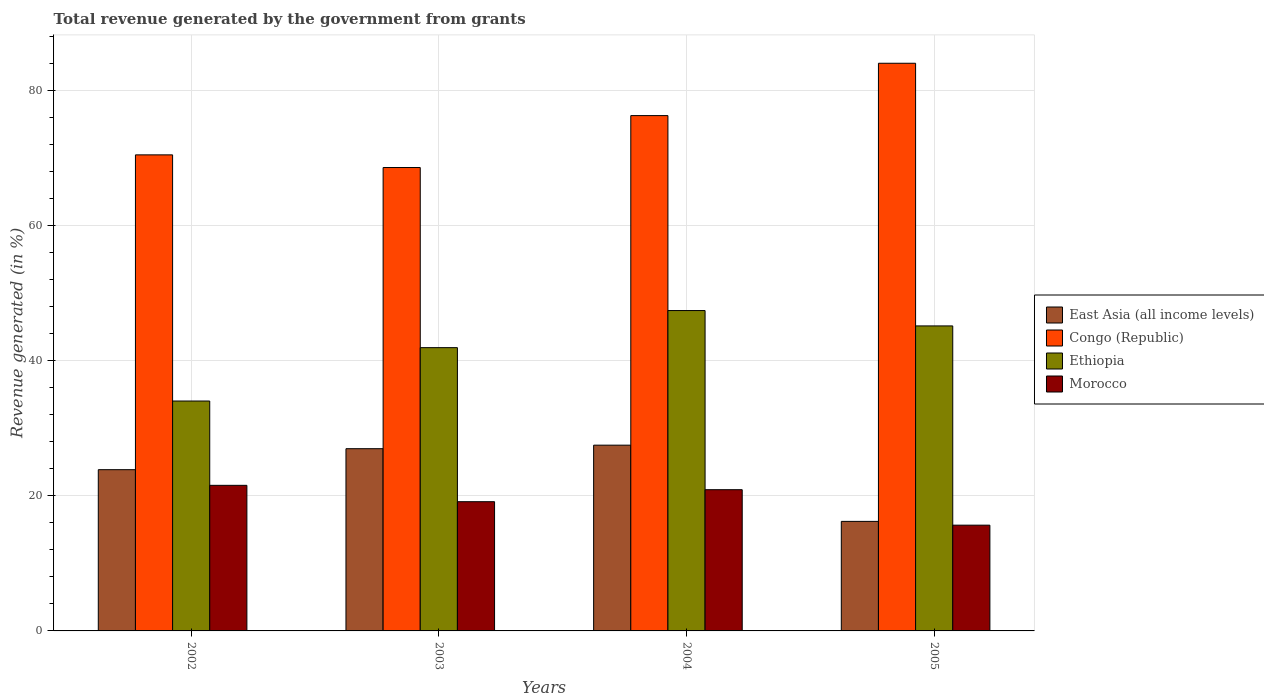How many different coloured bars are there?
Offer a terse response. 4. How many bars are there on the 1st tick from the right?
Ensure brevity in your answer.  4. What is the label of the 4th group of bars from the left?
Ensure brevity in your answer.  2005. In how many cases, is the number of bars for a given year not equal to the number of legend labels?
Your answer should be compact. 0. What is the total revenue generated in Congo (Republic) in 2004?
Make the answer very short. 76.32. Across all years, what is the maximum total revenue generated in Ethiopia?
Offer a very short reply. 47.45. Across all years, what is the minimum total revenue generated in Ethiopia?
Give a very brief answer. 34.05. In which year was the total revenue generated in Morocco maximum?
Offer a very short reply. 2002. What is the total total revenue generated in Morocco in the graph?
Your answer should be very brief. 77.28. What is the difference between the total revenue generated in Ethiopia in 2002 and that in 2003?
Provide a succinct answer. -7.91. What is the difference between the total revenue generated in Ethiopia in 2005 and the total revenue generated in East Asia (all income levels) in 2002?
Offer a very short reply. 21.29. What is the average total revenue generated in Morocco per year?
Give a very brief answer. 19.32. In the year 2004, what is the difference between the total revenue generated in East Asia (all income levels) and total revenue generated in Congo (Republic)?
Your answer should be compact. -48.81. In how many years, is the total revenue generated in Morocco greater than 64 %?
Your answer should be compact. 0. What is the ratio of the total revenue generated in Ethiopia in 2004 to that in 2005?
Your answer should be compact. 1.05. What is the difference between the highest and the second highest total revenue generated in Congo (Republic)?
Keep it short and to the point. 7.75. What is the difference between the highest and the lowest total revenue generated in Ethiopia?
Your answer should be very brief. 13.4. Is the sum of the total revenue generated in Ethiopia in 2004 and 2005 greater than the maximum total revenue generated in Morocco across all years?
Your answer should be very brief. Yes. What does the 4th bar from the left in 2002 represents?
Provide a short and direct response. Morocco. What does the 1st bar from the right in 2003 represents?
Provide a short and direct response. Morocco. How many bars are there?
Offer a very short reply. 16. Are all the bars in the graph horizontal?
Provide a succinct answer. No. Does the graph contain any zero values?
Your answer should be very brief. No. What is the title of the graph?
Make the answer very short. Total revenue generated by the government from grants. Does "Barbados" appear as one of the legend labels in the graph?
Make the answer very short. No. What is the label or title of the X-axis?
Your answer should be compact. Years. What is the label or title of the Y-axis?
Keep it short and to the point. Revenue generated (in %). What is the Revenue generated (in %) in East Asia (all income levels) in 2002?
Give a very brief answer. 23.88. What is the Revenue generated (in %) of Congo (Republic) in 2002?
Your answer should be compact. 70.51. What is the Revenue generated (in %) in Ethiopia in 2002?
Your answer should be compact. 34.05. What is the Revenue generated (in %) of Morocco in 2002?
Your answer should be compact. 21.56. What is the Revenue generated (in %) of East Asia (all income levels) in 2003?
Ensure brevity in your answer.  26.99. What is the Revenue generated (in %) in Congo (Republic) in 2003?
Provide a short and direct response. 68.63. What is the Revenue generated (in %) of Ethiopia in 2003?
Your answer should be compact. 41.96. What is the Revenue generated (in %) of Morocco in 2003?
Offer a terse response. 19.14. What is the Revenue generated (in %) in East Asia (all income levels) in 2004?
Ensure brevity in your answer.  27.51. What is the Revenue generated (in %) of Congo (Republic) in 2004?
Your answer should be very brief. 76.32. What is the Revenue generated (in %) in Ethiopia in 2004?
Provide a short and direct response. 47.45. What is the Revenue generated (in %) in Morocco in 2004?
Your answer should be very brief. 20.92. What is the Revenue generated (in %) of East Asia (all income levels) in 2005?
Your answer should be compact. 16.22. What is the Revenue generated (in %) of Congo (Republic) in 2005?
Your answer should be compact. 84.08. What is the Revenue generated (in %) of Ethiopia in 2005?
Your answer should be very brief. 45.17. What is the Revenue generated (in %) in Morocco in 2005?
Offer a terse response. 15.66. Across all years, what is the maximum Revenue generated (in %) of East Asia (all income levels)?
Provide a short and direct response. 27.51. Across all years, what is the maximum Revenue generated (in %) in Congo (Republic)?
Keep it short and to the point. 84.08. Across all years, what is the maximum Revenue generated (in %) of Ethiopia?
Offer a very short reply. 47.45. Across all years, what is the maximum Revenue generated (in %) in Morocco?
Your answer should be compact. 21.56. Across all years, what is the minimum Revenue generated (in %) in East Asia (all income levels)?
Provide a succinct answer. 16.22. Across all years, what is the minimum Revenue generated (in %) of Congo (Republic)?
Keep it short and to the point. 68.63. Across all years, what is the minimum Revenue generated (in %) in Ethiopia?
Provide a short and direct response. 34.05. Across all years, what is the minimum Revenue generated (in %) in Morocco?
Offer a very short reply. 15.66. What is the total Revenue generated (in %) in East Asia (all income levels) in the graph?
Your answer should be very brief. 94.61. What is the total Revenue generated (in %) in Congo (Republic) in the graph?
Give a very brief answer. 299.54. What is the total Revenue generated (in %) in Ethiopia in the graph?
Your answer should be compact. 168.63. What is the total Revenue generated (in %) of Morocco in the graph?
Your response must be concise. 77.28. What is the difference between the Revenue generated (in %) in East Asia (all income levels) in 2002 and that in 2003?
Offer a very short reply. -3.11. What is the difference between the Revenue generated (in %) of Congo (Republic) in 2002 and that in 2003?
Offer a terse response. 1.88. What is the difference between the Revenue generated (in %) of Ethiopia in 2002 and that in 2003?
Give a very brief answer. -7.91. What is the difference between the Revenue generated (in %) of Morocco in 2002 and that in 2003?
Provide a short and direct response. 2.42. What is the difference between the Revenue generated (in %) in East Asia (all income levels) in 2002 and that in 2004?
Give a very brief answer. -3.63. What is the difference between the Revenue generated (in %) of Congo (Republic) in 2002 and that in 2004?
Keep it short and to the point. -5.81. What is the difference between the Revenue generated (in %) of Ethiopia in 2002 and that in 2004?
Offer a terse response. -13.4. What is the difference between the Revenue generated (in %) in Morocco in 2002 and that in 2004?
Offer a terse response. 0.65. What is the difference between the Revenue generated (in %) of East Asia (all income levels) in 2002 and that in 2005?
Your answer should be very brief. 7.66. What is the difference between the Revenue generated (in %) in Congo (Republic) in 2002 and that in 2005?
Offer a terse response. -13.57. What is the difference between the Revenue generated (in %) of Ethiopia in 2002 and that in 2005?
Provide a short and direct response. -11.12. What is the difference between the Revenue generated (in %) in Morocco in 2002 and that in 2005?
Give a very brief answer. 5.9. What is the difference between the Revenue generated (in %) of East Asia (all income levels) in 2003 and that in 2004?
Provide a short and direct response. -0.52. What is the difference between the Revenue generated (in %) of Congo (Republic) in 2003 and that in 2004?
Give a very brief answer. -7.69. What is the difference between the Revenue generated (in %) of Ethiopia in 2003 and that in 2004?
Ensure brevity in your answer.  -5.49. What is the difference between the Revenue generated (in %) in Morocco in 2003 and that in 2004?
Your answer should be compact. -1.78. What is the difference between the Revenue generated (in %) in East Asia (all income levels) in 2003 and that in 2005?
Offer a terse response. 10.77. What is the difference between the Revenue generated (in %) of Congo (Republic) in 2003 and that in 2005?
Ensure brevity in your answer.  -15.44. What is the difference between the Revenue generated (in %) in Ethiopia in 2003 and that in 2005?
Your answer should be compact. -3.22. What is the difference between the Revenue generated (in %) in Morocco in 2003 and that in 2005?
Provide a succinct answer. 3.48. What is the difference between the Revenue generated (in %) in East Asia (all income levels) in 2004 and that in 2005?
Provide a succinct answer. 11.29. What is the difference between the Revenue generated (in %) in Congo (Republic) in 2004 and that in 2005?
Provide a succinct answer. -7.75. What is the difference between the Revenue generated (in %) of Ethiopia in 2004 and that in 2005?
Provide a short and direct response. 2.27. What is the difference between the Revenue generated (in %) of Morocco in 2004 and that in 2005?
Keep it short and to the point. 5.25. What is the difference between the Revenue generated (in %) in East Asia (all income levels) in 2002 and the Revenue generated (in %) in Congo (Republic) in 2003?
Offer a very short reply. -44.75. What is the difference between the Revenue generated (in %) of East Asia (all income levels) in 2002 and the Revenue generated (in %) of Ethiopia in 2003?
Offer a very short reply. -18.07. What is the difference between the Revenue generated (in %) in East Asia (all income levels) in 2002 and the Revenue generated (in %) in Morocco in 2003?
Ensure brevity in your answer.  4.74. What is the difference between the Revenue generated (in %) in Congo (Republic) in 2002 and the Revenue generated (in %) in Ethiopia in 2003?
Your response must be concise. 28.55. What is the difference between the Revenue generated (in %) of Congo (Republic) in 2002 and the Revenue generated (in %) of Morocco in 2003?
Provide a short and direct response. 51.37. What is the difference between the Revenue generated (in %) of Ethiopia in 2002 and the Revenue generated (in %) of Morocco in 2003?
Your response must be concise. 14.91. What is the difference between the Revenue generated (in %) of East Asia (all income levels) in 2002 and the Revenue generated (in %) of Congo (Republic) in 2004?
Give a very brief answer. -52.44. What is the difference between the Revenue generated (in %) of East Asia (all income levels) in 2002 and the Revenue generated (in %) of Ethiopia in 2004?
Make the answer very short. -23.57. What is the difference between the Revenue generated (in %) in East Asia (all income levels) in 2002 and the Revenue generated (in %) in Morocco in 2004?
Provide a short and direct response. 2.97. What is the difference between the Revenue generated (in %) in Congo (Republic) in 2002 and the Revenue generated (in %) in Ethiopia in 2004?
Keep it short and to the point. 23.06. What is the difference between the Revenue generated (in %) in Congo (Republic) in 2002 and the Revenue generated (in %) in Morocco in 2004?
Ensure brevity in your answer.  49.59. What is the difference between the Revenue generated (in %) in Ethiopia in 2002 and the Revenue generated (in %) in Morocco in 2004?
Provide a succinct answer. 13.13. What is the difference between the Revenue generated (in %) in East Asia (all income levels) in 2002 and the Revenue generated (in %) in Congo (Republic) in 2005?
Offer a terse response. -60.19. What is the difference between the Revenue generated (in %) in East Asia (all income levels) in 2002 and the Revenue generated (in %) in Ethiopia in 2005?
Your answer should be compact. -21.29. What is the difference between the Revenue generated (in %) in East Asia (all income levels) in 2002 and the Revenue generated (in %) in Morocco in 2005?
Offer a terse response. 8.22. What is the difference between the Revenue generated (in %) of Congo (Republic) in 2002 and the Revenue generated (in %) of Ethiopia in 2005?
Keep it short and to the point. 25.34. What is the difference between the Revenue generated (in %) of Congo (Republic) in 2002 and the Revenue generated (in %) of Morocco in 2005?
Keep it short and to the point. 54.84. What is the difference between the Revenue generated (in %) in Ethiopia in 2002 and the Revenue generated (in %) in Morocco in 2005?
Provide a short and direct response. 18.38. What is the difference between the Revenue generated (in %) in East Asia (all income levels) in 2003 and the Revenue generated (in %) in Congo (Republic) in 2004?
Offer a terse response. -49.33. What is the difference between the Revenue generated (in %) in East Asia (all income levels) in 2003 and the Revenue generated (in %) in Ethiopia in 2004?
Keep it short and to the point. -20.46. What is the difference between the Revenue generated (in %) of East Asia (all income levels) in 2003 and the Revenue generated (in %) of Morocco in 2004?
Offer a terse response. 6.07. What is the difference between the Revenue generated (in %) of Congo (Republic) in 2003 and the Revenue generated (in %) of Ethiopia in 2004?
Make the answer very short. 21.18. What is the difference between the Revenue generated (in %) in Congo (Republic) in 2003 and the Revenue generated (in %) in Morocco in 2004?
Your answer should be compact. 47.72. What is the difference between the Revenue generated (in %) of Ethiopia in 2003 and the Revenue generated (in %) of Morocco in 2004?
Keep it short and to the point. 21.04. What is the difference between the Revenue generated (in %) of East Asia (all income levels) in 2003 and the Revenue generated (in %) of Congo (Republic) in 2005?
Offer a very short reply. -57.09. What is the difference between the Revenue generated (in %) in East Asia (all income levels) in 2003 and the Revenue generated (in %) in Ethiopia in 2005?
Your answer should be very brief. -18.19. What is the difference between the Revenue generated (in %) of East Asia (all income levels) in 2003 and the Revenue generated (in %) of Morocco in 2005?
Offer a very short reply. 11.32. What is the difference between the Revenue generated (in %) of Congo (Republic) in 2003 and the Revenue generated (in %) of Ethiopia in 2005?
Ensure brevity in your answer.  23.46. What is the difference between the Revenue generated (in %) of Congo (Republic) in 2003 and the Revenue generated (in %) of Morocco in 2005?
Your answer should be compact. 52.97. What is the difference between the Revenue generated (in %) in Ethiopia in 2003 and the Revenue generated (in %) in Morocco in 2005?
Your answer should be compact. 26.29. What is the difference between the Revenue generated (in %) of East Asia (all income levels) in 2004 and the Revenue generated (in %) of Congo (Republic) in 2005?
Give a very brief answer. -56.56. What is the difference between the Revenue generated (in %) of East Asia (all income levels) in 2004 and the Revenue generated (in %) of Ethiopia in 2005?
Offer a very short reply. -17.66. What is the difference between the Revenue generated (in %) in East Asia (all income levels) in 2004 and the Revenue generated (in %) in Morocco in 2005?
Make the answer very short. 11.85. What is the difference between the Revenue generated (in %) of Congo (Republic) in 2004 and the Revenue generated (in %) of Ethiopia in 2005?
Offer a terse response. 31.15. What is the difference between the Revenue generated (in %) of Congo (Republic) in 2004 and the Revenue generated (in %) of Morocco in 2005?
Your answer should be compact. 60.66. What is the difference between the Revenue generated (in %) in Ethiopia in 2004 and the Revenue generated (in %) in Morocco in 2005?
Your answer should be compact. 31.78. What is the average Revenue generated (in %) in East Asia (all income levels) per year?
Make the answer very short. 23.65. What is the average Revenue generated (in %) in Congo (Republic) per year?
Provide a short and direct response. 74.88. What is the average Revenue generated (in %) in Ethiopia per year?
Ensure brevity in your answer.  42.16. What is the average Revenue generated (in %) in Morocco per year?
Your answer should be very brief. 19.32. In the year 2002, what is the difference between the Revenue generated (in %) in East Asia (all income levels) and Revenue generated (in %) in Congo (Republic)?
Keep it short and to the point. -46.63. In the year 2002, what is the difference between the Revenue generated (in %) in East Asia (all income levels) and Revenue generated (in %) in Ethiopia?
Ensure brevity in your answer.  -10.17. In the year 2002, what is the difference between the Revenue generated (in %) in East Asia (all income levels) and Revenue generated (in %) in Morocco?
Offer a very short reply. 2.32. In the year 2002, what is the difference between the Revenue generated (in %) of Congo (Republic) and Revenue generated (in %) of Ethiopia?
Offer a very short reply. 36.46. In the year 2002, what is the difference between the Revenue generated (in %) of Congo (Republic) and Revenue generated (in %) of Morocco?
Provide a succinct answer. 48.95. In the year 2002, what is the difference between the Revenue generated (in %) of Ethiopia and Revenue generated (in %) of Morocco?
Your answer should be very brief. 12.49. In the year 2003, what is the difference between the Revenue generated (in %) in East Asia (all income levels) and Revenue generated (in %) in Congo (Republic)?
Give a very brief answer. -41.64. In the year 2003, what is the difference between the Revenue generated (in %) of East Asia (all income levels) and Revenue generated (in %) of Ethiopia?
Make the answer very short. -14.97. In the year 2003, what is the difference between the Revenue generated (in %) in East Asia (all income levels) and Revenue generated (in %) in Morocco?
Provide a succinct answer. 7.85. In the year 2003, what is the difference between the Revenue generated (in %) of Congo (Republic) and Revenue generated (in %) of Ethiopia?
Provide a succinct answer. 26.68. In the year 2003, what is the difference between the Revenue generated (in %) of Congo (Republic) and Revenue generated (in %) of Morocco?
Your answer should be compact. 49.49. In the year 2003, what is the difference between the Revenue generated (in %) in Ethiopia and Revenue generated (in %) in Morocco?
Offer a very short reply. 22.82. In the year 2004, what is the difference between the Revenue generated (in %) of East Asia (all income levels) and Revenue generated (in %) of Congo (Republic)?
Give a very brief answer. -48.81. In the year 2004, what is the difference between the Revenue generated (in %) of East Asia (all income levels) and Revenue generated (in %) of Ethiopia?
Provide a short and direct response. -19.94. In the year 2004, what is the difference between the Revenue generated (in %) of East Asia (all income levels) and Revenue generated (in %) of Morocco?
Give a very brief answer. 6.6. In the year 2004, what is the difference between the Revenue generated (in %) in Congo (Republic) and Revenue generated (in %) in Ethiopia?
Keep it short and to the point. 28.87. In the year 2004, what is the difference between the Revenue generated (in %) of Congo (Republic) and Revenue generated (in %) of Morocco?
Provide a short and direct response. 55.41. In the year 2004, what is the difference between the Revenue generated (in %) of Ethiopia and Revenue generated (in %) of Morocco?
Keep it short and to the point. 26.53. In the year 2005, what is the difference between the Revenue generated (in %) of East Asia (all income levels) and Revenue generated (in %) of Congo (Republic)?
Ensure brevity in your answer.  -67.85. In the year 2005, what is the difference between the Revenue generated (in %) of East Asia (all income levels) and Revenue generated (in %) of Ethiopia?
Your answer should be compact. -28.95. In the year 2005, what is the difference between the Revenue generated (in %) in East Asia (all income levels) and Revenue generated (in %) in Morocco?
Your response must be concise. 0.56. In the year 2005, what is the difference between the Revenue generated (in %) in Congo (Republic) and Revenue generated (in %) in Ethiopia?
Your response must be concise. 38.9. In the year 2005, what is the difference between the Revenue generated (in %) of Congo (Republic) and Revenue generated (in %) of Morocco?
Make the answer very short. 68.41. In the year 2005, what is the difference between the Revenue generated (in %) in Ethiopia and Revenue generated (in %) in Morocco?
Give a very brief answer. 29.51. What is the ratio of the Revenue generated (in %) in East Asia (all income levels) in 2002 to that in 2003?
Offer a terse response. 0.88. What is the ratio of the Revenue generated (in %) of Congo (Republic) in 2002 to that in 2003?
Offer a very short reply. 1.03. What is the ratio of the Revenue generated (in %) of Ethiopia in 2002 to that in 2003?
Keep it short and to the point. 0.81. What is the ratio of the Revenue generated (in %) of Morocco in 2002 to that in 2003?
Keep it short and to the point. 1.13. What is the ratio of the Revenue generated (in %) in East Asia (all income levels) in 2002 to that in 2004?
Offer a terse response. 0.87. What is the ratio of the Revenue generated (in %) of Congo (Republic) in 2002 to that in 2004?
Your response must be concise. 0.92. What is the ratio of the Revenue generated (in %) of Ethiopia in 2002 to that in 2004?
Your answer should be very brief. 0.72. What is the ratio of the Revenue generated (in %) in Morocco in 2002 to that in 2004?
Your response must be concise. 1.03. What is the ratio of the Revenue generated (in %) in East Asia (all income levels) in 2002 to that in 2005?
Your answer should be very brief. 1.47. What is the ratio of the Revenue generated (in %) of Congo (Republic) in 2002 to that in 2005?
Keep it short and to the point. 0.84. What is the ratio of the Revenue generated (in %) of Ethiopia in 2002 to that in 2005?
Ensure brevity in your answer.  0.75. What is the ratio of the Revenue generated (in %) of Morocco in 2002 to that in 2005?
Offer a terse response. 1.38. What is the ratio of the Revenue generated (in %) of East Asia (all income levels) in 2003 to that in 2004?
Offer a terse response. 0.98. What is the ratio of the Revenue generated (in %) of Congo (Republic) in 2003 to that in 2004?
Make the answer very short. 0.9. What is the ratio of the Revenue generated (in %) of Ethiopia in 2003 to that in 2004?
Your answer should be compact. 0.88. What is the ratio of the Revenue generated (in %) in Morocco in 2003 to that in 2004?
Offer a terse response. 0.92. What is the ratio of the Revenue generated (in %) of East Asia (all income levels) in 2003 to that in 2005?
Your answer should be compact. 1.66. What is the ratio of the Revenue generated (in %) in Congo (Republic) in 2003 to that in 2005?
Your response must be concise. 0.82. What is the ratio of the Revenue generated (in %) in Ethiopia in 2003 to that in 2005?
Offer a very short reply. 0.93. What is the ratio of the Revenue generated (in %) of Morocco in 2003 to that in 2005?
Offer a very short reply. 1.22. What is the ratio of the Revenue generated (in %) in East Asia (all income levels) in 2004 to that in 2005?
Offer a terse response. 1.7. What is the ratio of the Revenue generated (in %) of Congo (Republic) in 2004 to that in 2005?
Your response must be concise. 0.91. What is the ratio of the Revenue generated (in %) of Ethiopia in 2004 to that in 2005?
Provide a succinct answer. 1.05. What is the ratio of the Revenue generated (in %) in Morocco in 2004 to that in 2005?
Your answer should be very brief. 1.34. What is the difference between the highest and the second highest Revenue generated (in %) of East Asia (all income levels)?
Your answer should be compact. 0.52. What is the difference between the highest and the second highest Revenue generated (in %) in Congo (Republic)?
Offer a terse response. 7.75. What is the difference between the highest and the second highest Revenue generated (in %) in Ethiopia?
Provide a short and direct response. 2.27. What is the difference between the highest and the second highest Revenue generated (in %) of Morocco?
Offer a very short reply. 0.65. What is the difference between the highest and the lowest Revenue generated (in %) of East Asia (all income levels)?
Your answer should be very brief. 11.29. What is the difference between the highest and the lowest Revenue generated (in %) of Congo (Republic)?
Give a very brief answer. 15.44. What is the difference between the highest and the lowest Revenue generated (in %) of Ethiopia?
Keep it short and to the point. 13.4. What is the difference between the highest and the lowest Revenue generated (in %) of Morocco?
Ensure brevity in your answer.  5.9. 